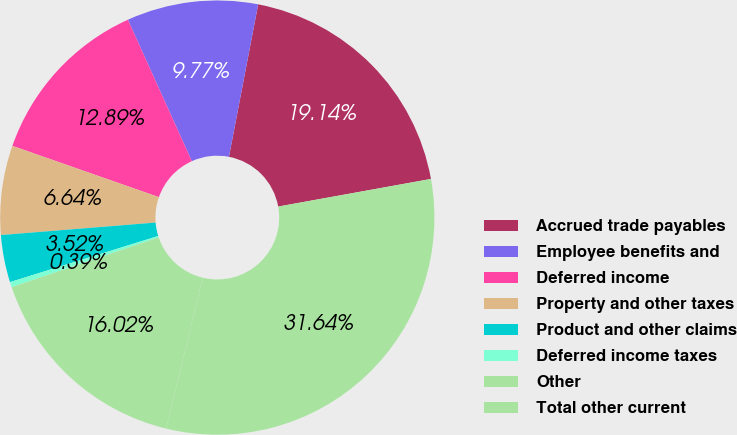Convert chart to OTSL. <chart><loc_0><loc_0><loc_500><loc_500><pie_chart><fcel>Accrued trade payables<fcel>Employee benefits and<fcel>Deferred income<fcel>Property and other taxes<fcel>Product and other claims<fcel>Deferred income taxes<fcel>Other<fcel>Total other current<nl><fcel>19.14%<fcel>9.77%<fcel>12.89%<fcel>6.64%<fcel>3.52%<fcel>0.39%<fcel>16.02%<fcel>31.64%<nl></chart> 